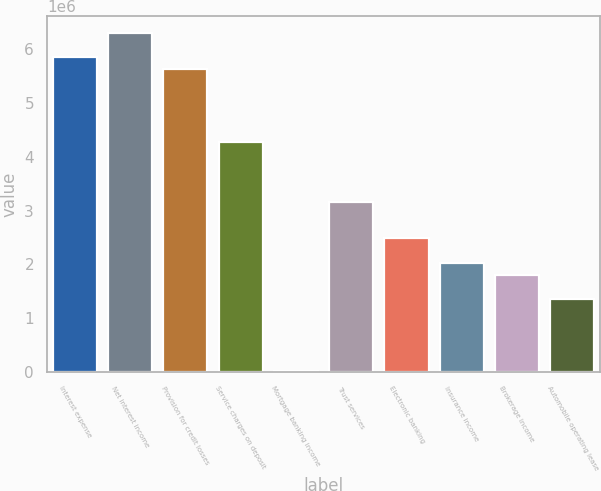Convert chart. <chart><loc_0><loc_0><loc_500><loc_500><bar_chart><fcel>Interest expense<fcel>Net interest income<fcel>Provision for credit losses<fcel>Service charges on deposit<fcel>Mortgage banking income<fcel>Trust services<fcel>Electronic banking<fcel>Insurance income<fcel>Brokerage income<fcel>Automobile operating lease<nl><fcel>5.85913e+06<fcel>6.30914e+06<fcel>5.63413e+06<fcel>4.28409e+06<fcel>8994<fcel>3.15907e+06<fcel>2.48405e+06<fcel>2.03404e+06<fcel>1.80904e+06<fcel>1.35903e+06<nl></chart> 